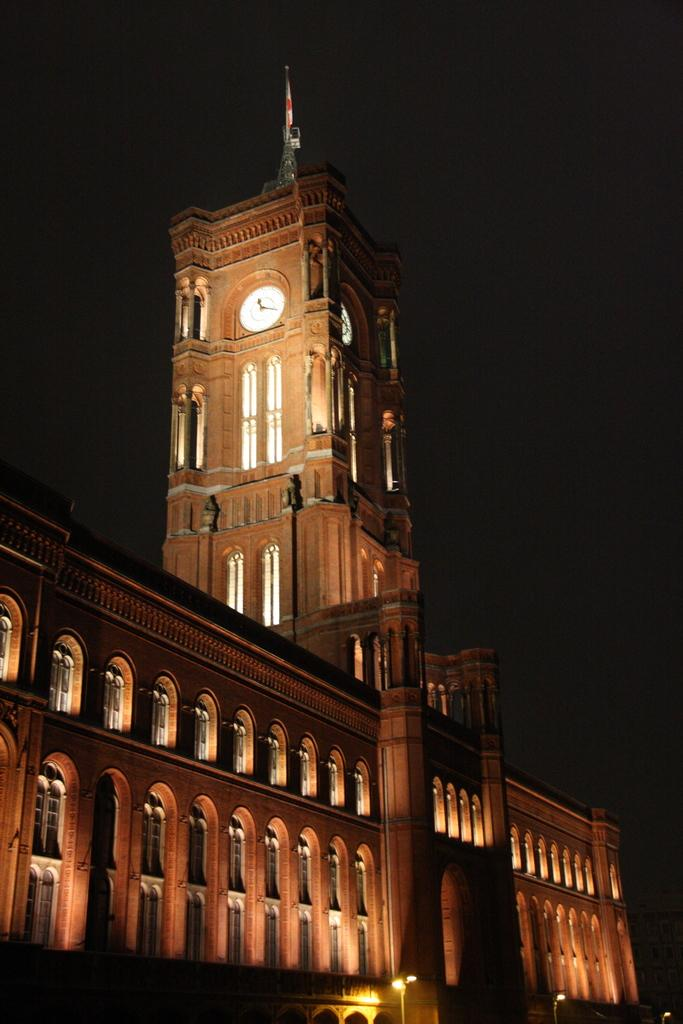What is the lighting condition in the image? The image was taken in the dark. What type of structure can be seen in the image? There is a building in the image. Is there any specific feature on the building? Yes, there is a clock tower in the image. What can be seen at the bottom of the image? There are light poles at the bottom of the image. How would you describe the overall appearance of the image? The background of the image is dark. What verse from a book can be seen written on the clock tower in the image? There is no verse from a book visible on the clock tower in the image. How many eggs are present on the light poles in the image? There are no eggs present on the light poles in the image. 